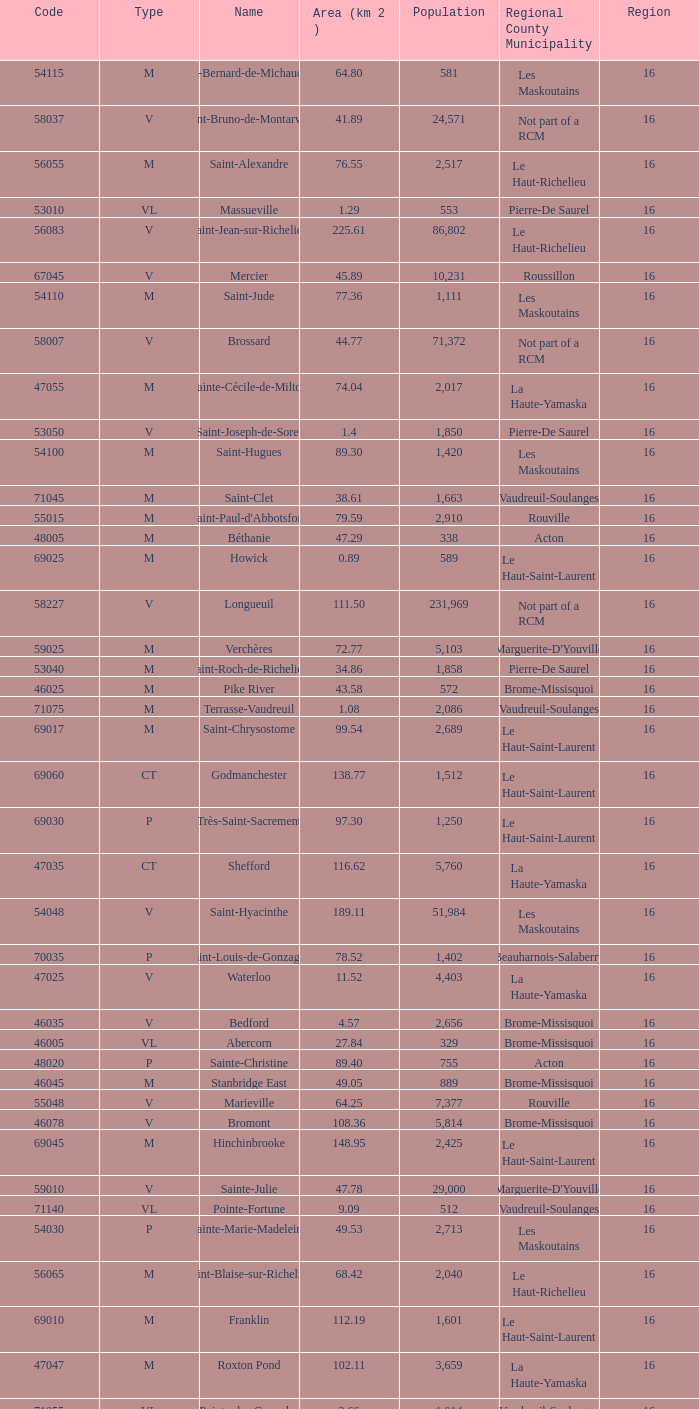Cowansville has less than 16 regions and is a Brome-Missisquoi Municipality, what is their population? None. 